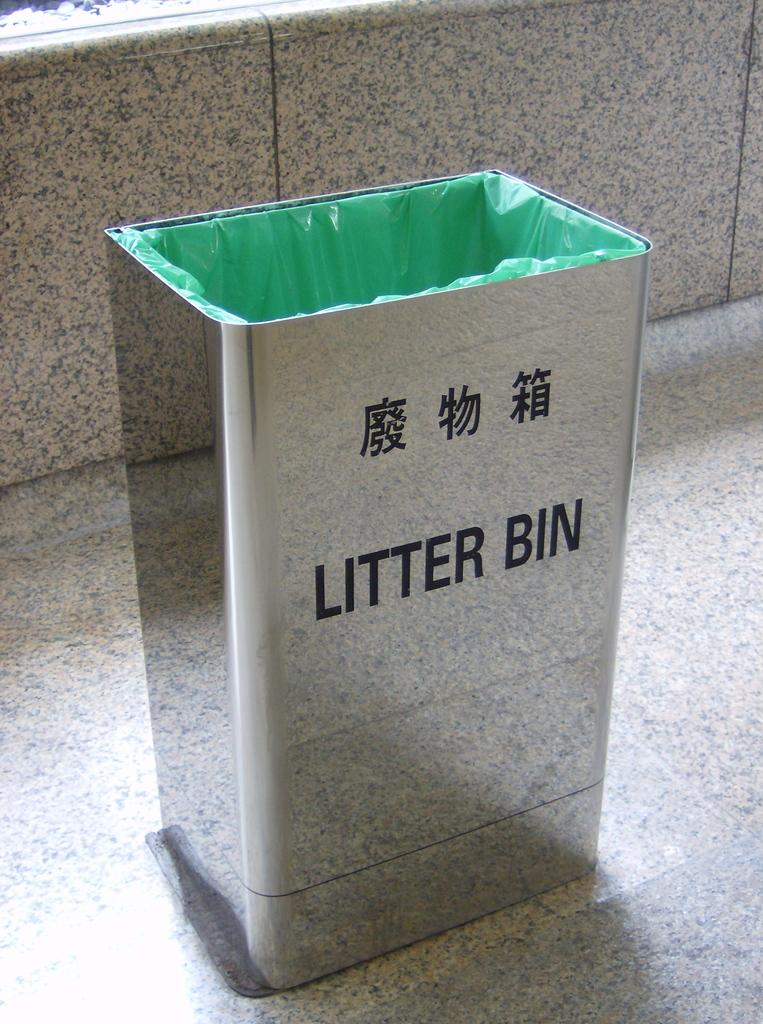<image>
Render a clear and concise summary of the photo. The sliver trash can also has a foreign writing on it. 